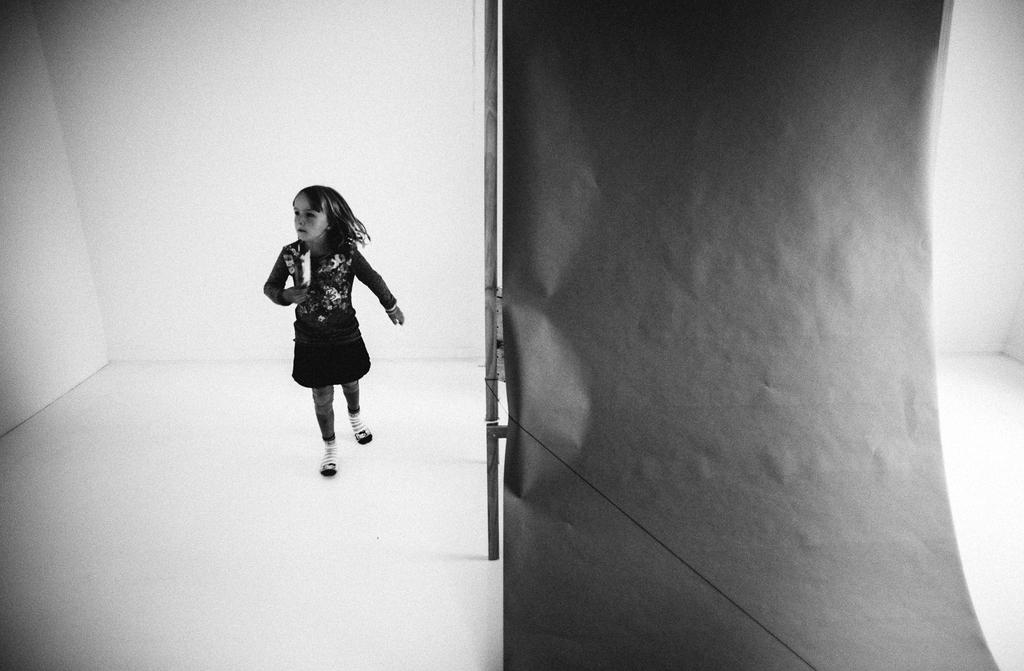Who is the main subject in the image? There is a girl in the image. What is the girl doing in the image? The girl is running. What is the girl wearing in the image? The girl is wearing a dress. What is the color scheme of the image? The image is in black and white color. Where is the zipper located on the girl's dress in the image? There is no zipper present on the girl's dress in the image, as the dress is not described in detail. 